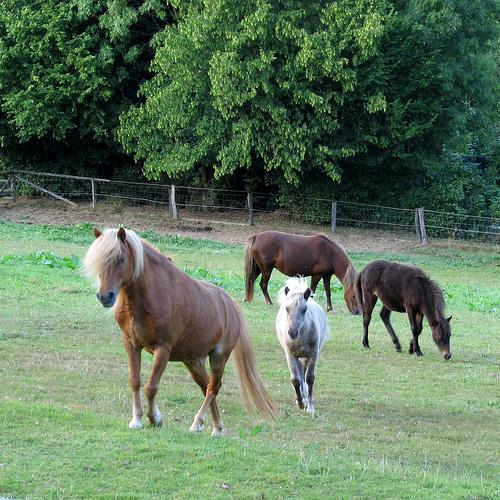Question: what is standing?
Choices:
A. Cats.
B. Horses.
C. Men.
D. Children.
Answer with the letter. Answer: B Question: where are the horses?
Choices:
A. The barn.
B. The track.
C. Field.
D. The forest.
Answer with the letter. Answer: C Question: how many horses?
Choices:
A. 3.
B. 2.
C. 1.
D. 4.
Answer with the letter. Answer: D Question: what is behind the horses?
Choices:
A. Trees.
B. Bushes.
C. Grass.
D. Fence.
Answer with the letter. Answer: A 